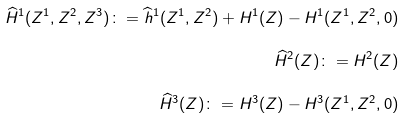Convert formula to latex. <formula><loc_0><loc_0><loc_500><loc_500>\widehat { H } ^ { 1 } ( Z ^ { 1 } , Z ^ { 2 } , Z ^ { 3 } ) \colon = \widehat { h } ^ { 1 } ( Z ^ { 1 } , Z ^ { 2 } ) + H ^ { 1 } ( Z ) - H ^ { 1 } ( Z ^ { 1 } , Z ^ { 2 } , 0 ) \\ \widehat { H } ^ { 2 } ( Z ) \colon = H ^ { 2 } ( Z ) \\ \widehat { H } ^ { 3 } ( Z ) \colon = H ^ { 3 } ( Z ) - H ^ { 3 } ( Z ^ { 1 } , Z ^ { 2 } , 0 )</formula> 